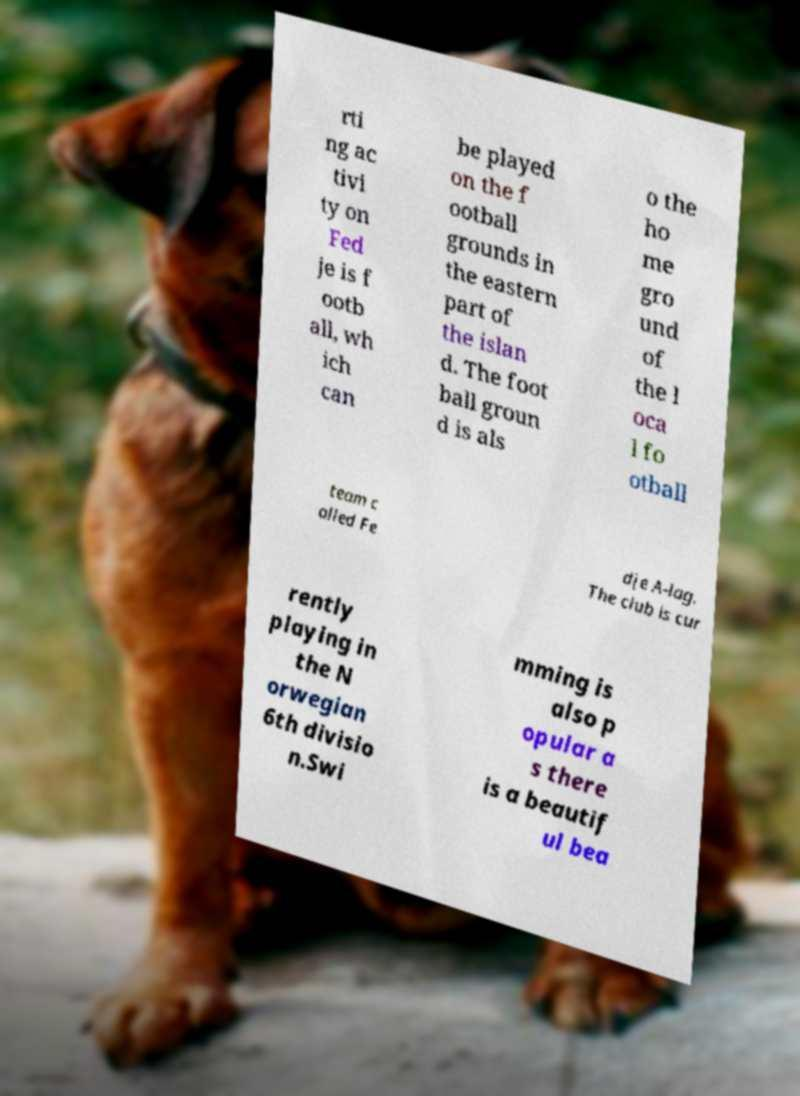There's text embedded in this image that I need extracted. Can you transcribe it verbatim? rti ng ac tivi ty on Fed je is f ootb all, wh ich can be played on the f ootball grounds in the eastern part of the islan d. The foot ball groun d is als o the ho me gro und of the l oca l fo otball team c alled Fe dje A-lag. The club is cur rently playing in the N orwegian 6th divisio n.Swi mming is also p opular a s there is a beautif ul bea 